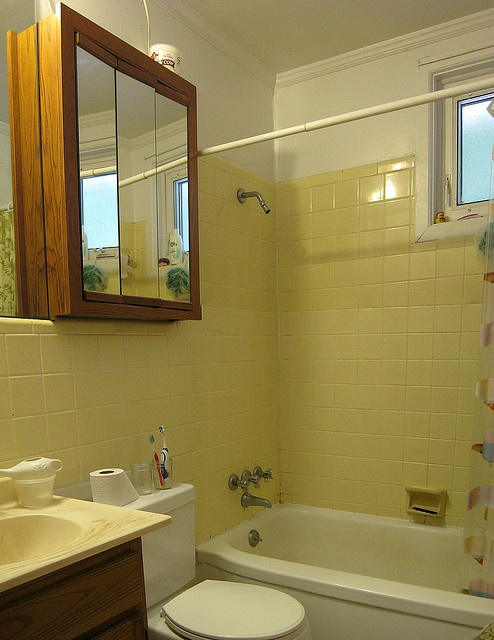Describe the objects in this image and their specific colors. I can see sink in tan and khaki tones, toilet in tan and olive tones, bowl in tan and olive tones, cup in tan and olive tones, and cup in tan and olive tones in this image. 